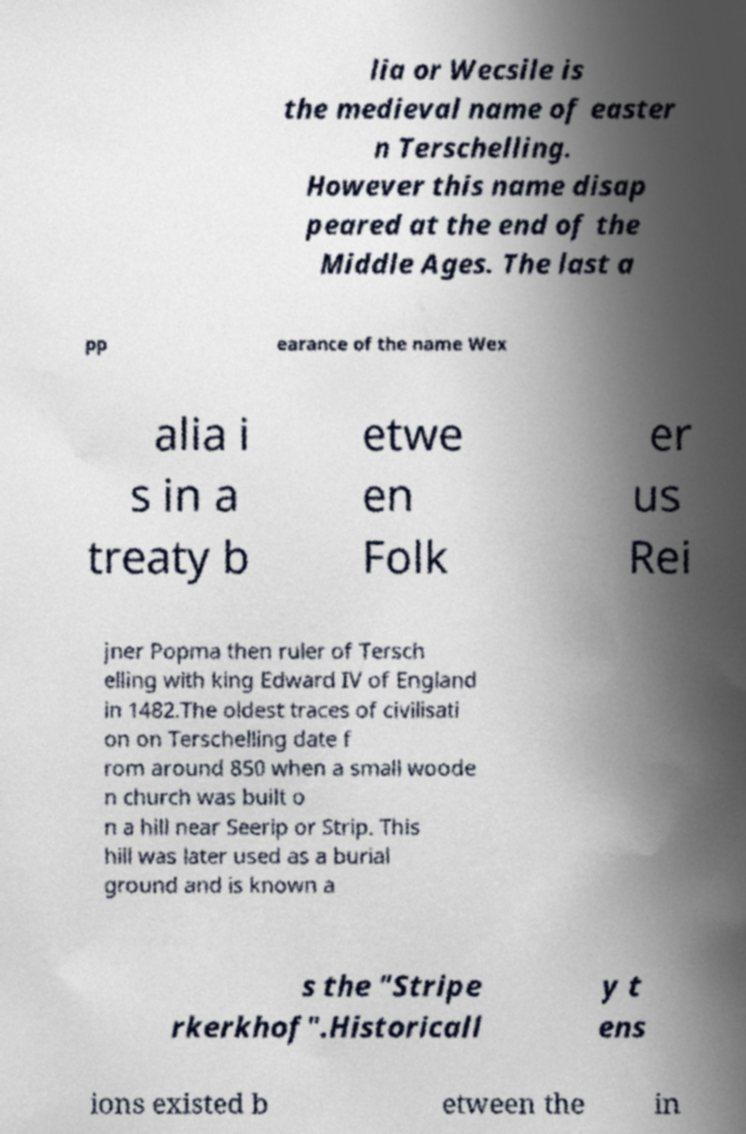For documentation purposes, I need the text within this image transcribed. Could you provide that? lia or Wecsile is the medieval name of easter n Terschelling. However this name disap peared at the end of the Middle Ages. The last a pp earance of the name Wex alia i s in a treaty b etwe en Folk er us Rei jner Popma then ruler of Tersch elling with king Edward IV of England in 1482.The oldest traces of civilisati on on Terschelling date f rom around 850 when a small woode n church was built o n a hill near Seerip or Strip. This hill was later used as a burial ground and is known a s the "Stripe rkerkhof".Historicall y t ens ions existed b etween the in 